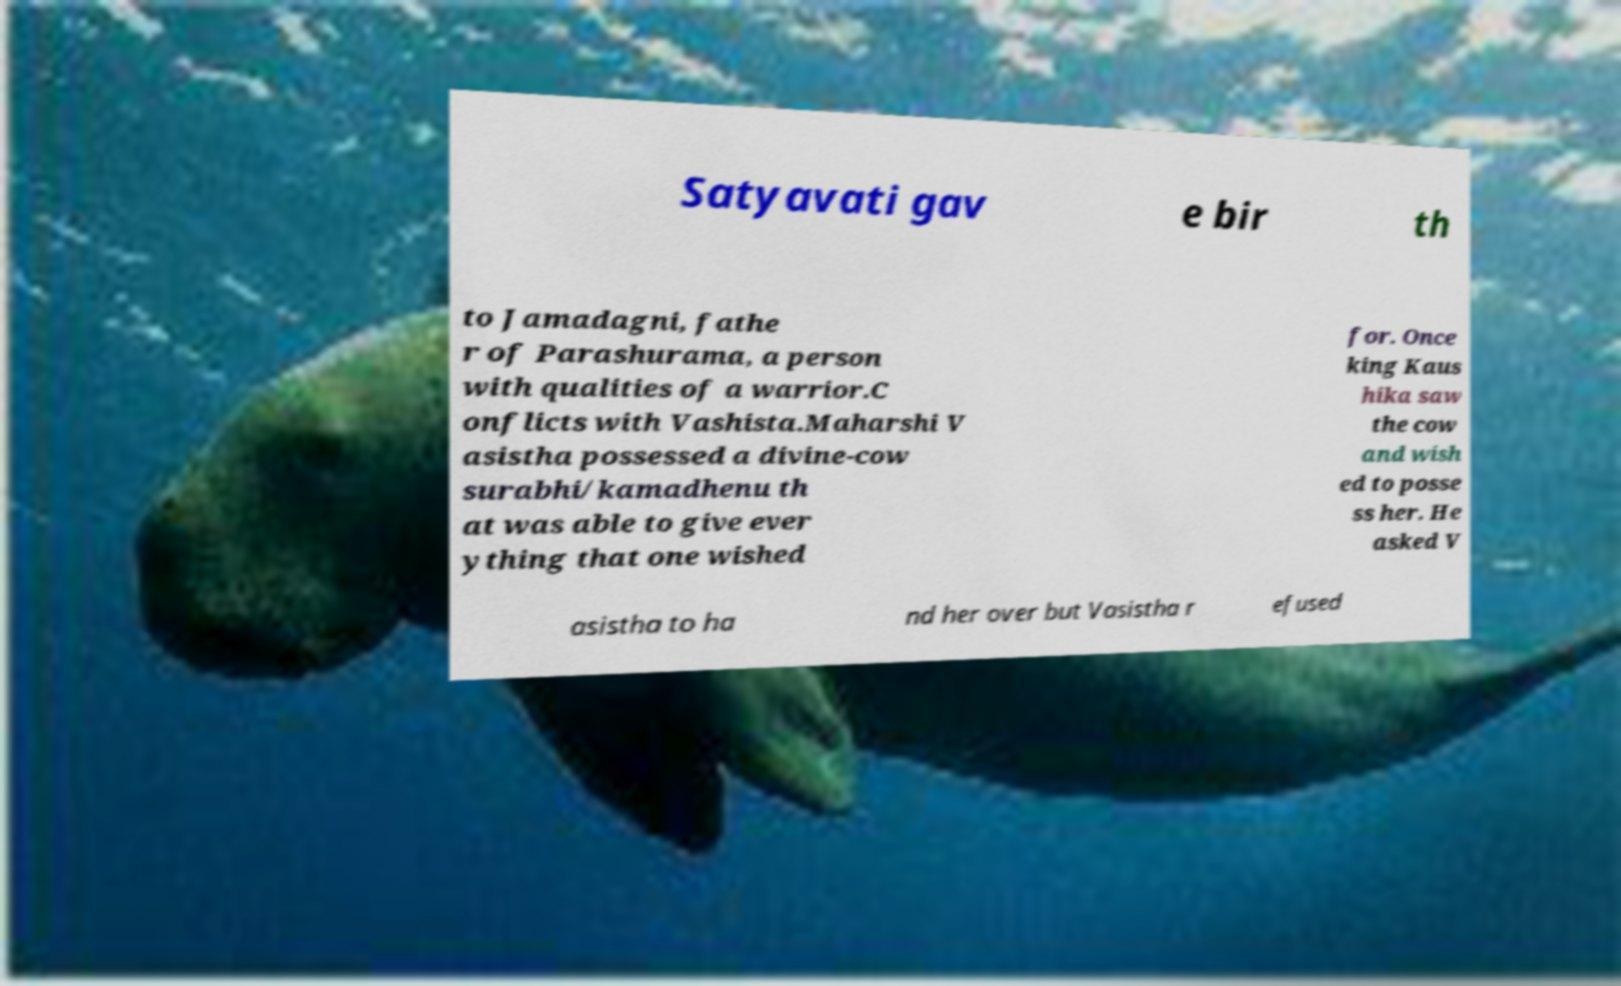Could you extract and type out the text from this image? Satyavati gav e bir th to Jamadagni, fathe r of Parashurama, a person with qualities of a warrior.C onflicts with Vashista.Maharshi V asistha possessed a divine-cow surabhi/kamadhenu th at was able to give ever ything that one wished for. Once king Kaus hika saw the cow and wish ed to posse ss her. He asked V asistha to ha nd her over but Vasistha r efused 